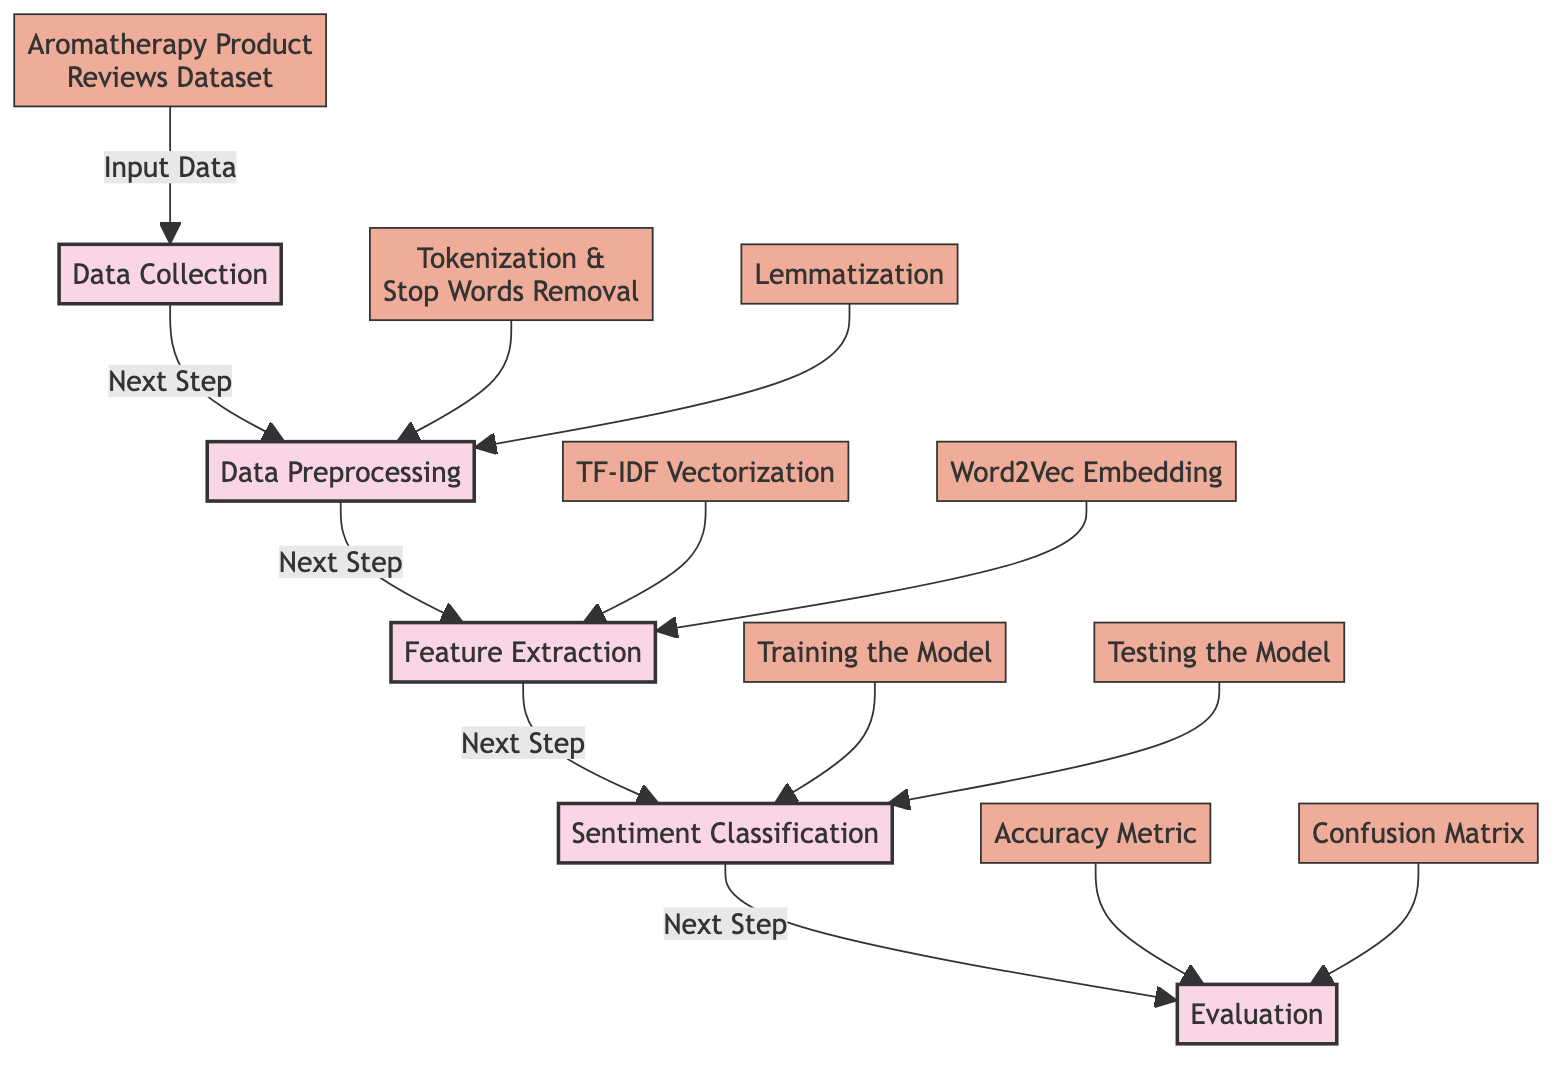What is the first step in the diagram? The first step in the diagram is represented by node 1, which is labeled "Data Collection." This node is connected to the input data node, indicating it is the starting point of the process.
Answer: Data Collection How many main nodes are in the diagram? There are five main nodes in the diagram. Each main node represents a key step in the sentiment analysis process, which are Data Collection, Data Preprocessing, Feature Extraction, Sentiment Classification, and Evaluation.
Answer: 5 What is the output of the "Feature Extraction" step? The output of the "Feature Extraction" step consists of two methods represented by nodes 9 and 10, which are "TF-IDF Vectorization" and "Word2Vec Embedding." The flow shows that both are connected to the "Feature Extraction" node.
Answer: TF-IDF Vectorization, Word2Vec Embedding What connects the "Aromatherapy Product Reviews Dataset" to the first node? The connection from the "Aromatherapy Product Reviews Dataset" to the first node is labeled "Input Data." This indicates that the dataset is utilized as the input for the Data Collection step.
Answer: Input Data Which step comes after "Data Preprocessing"? The step that comes after "Data Preprocessing" is "Feature Extraction," as indicated by the arrows showing the direction of flow from node 2 to node 3.
Answer: Feature Extraction What evaluation metrics are mentioned in the diagram? The evaluation metrics mentioned in the diagram include "Accuracy Metric" and "Confusion Matrix," which are nodes connected to the Evaluation step and help assess the performance of the sentiment classification model.
Answer: Accuracy Metric, Confusion Matrix What is performed after "Training the Model"? After "Training the Model," the next step indicated is "Testing the Model," as per the directional flow in the diagram connecting node 11 to node 12 directly.
Answer: Testing the Model Which processes are part of "Data Preprocessing"? The processes of "Tokenization & Stop Words Removal" and "Lemmatization" are part of "Data Preprocessing," as shown by nodes 7 and 8 connecting directly to the Data Preprocessing main node.
Answer: Tokenization & Stop Words Removal, Lemmatization 